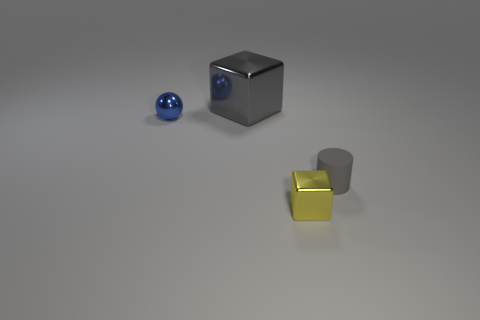The small metallic thing in front of the blue metal ball has what shape?
Ensure brevity in your answer.  Cube. There is a shiny block that is in front of the metallic cube to the left of the tiny yellow shiny block; are there any big gray things on the right side of it?
Provide a short and direct response. No. Are there any other things that have the same shape as the tiny blue thing?
Ensure brevity in your answer.  No. Are any blue rubber things visible?
Your answer should be very brief. No. Is the material of the block in front of the big gray block the same as the small object that is left of the gray metal object?
Provide a succinct answer. Yes. What size is the block in front of the cube behind the gray thing that is on the right side of the large gray metal cube?
Make the answer very short. Small. What number of tiny cubes are the same material as the yellow thing?
Offer a terse response. 0. Is the number of tiny gray cylinders less than the number of small cyan metallic blocks?
Give a very brief answer. No. What size is the yellow thing that is the same shape as the large gray shiny thing?
Keep it short and to the point. Small. Do the gray thing in front of the gray cube and the big gray cube have the same material?
Give a very brief answer. No. 